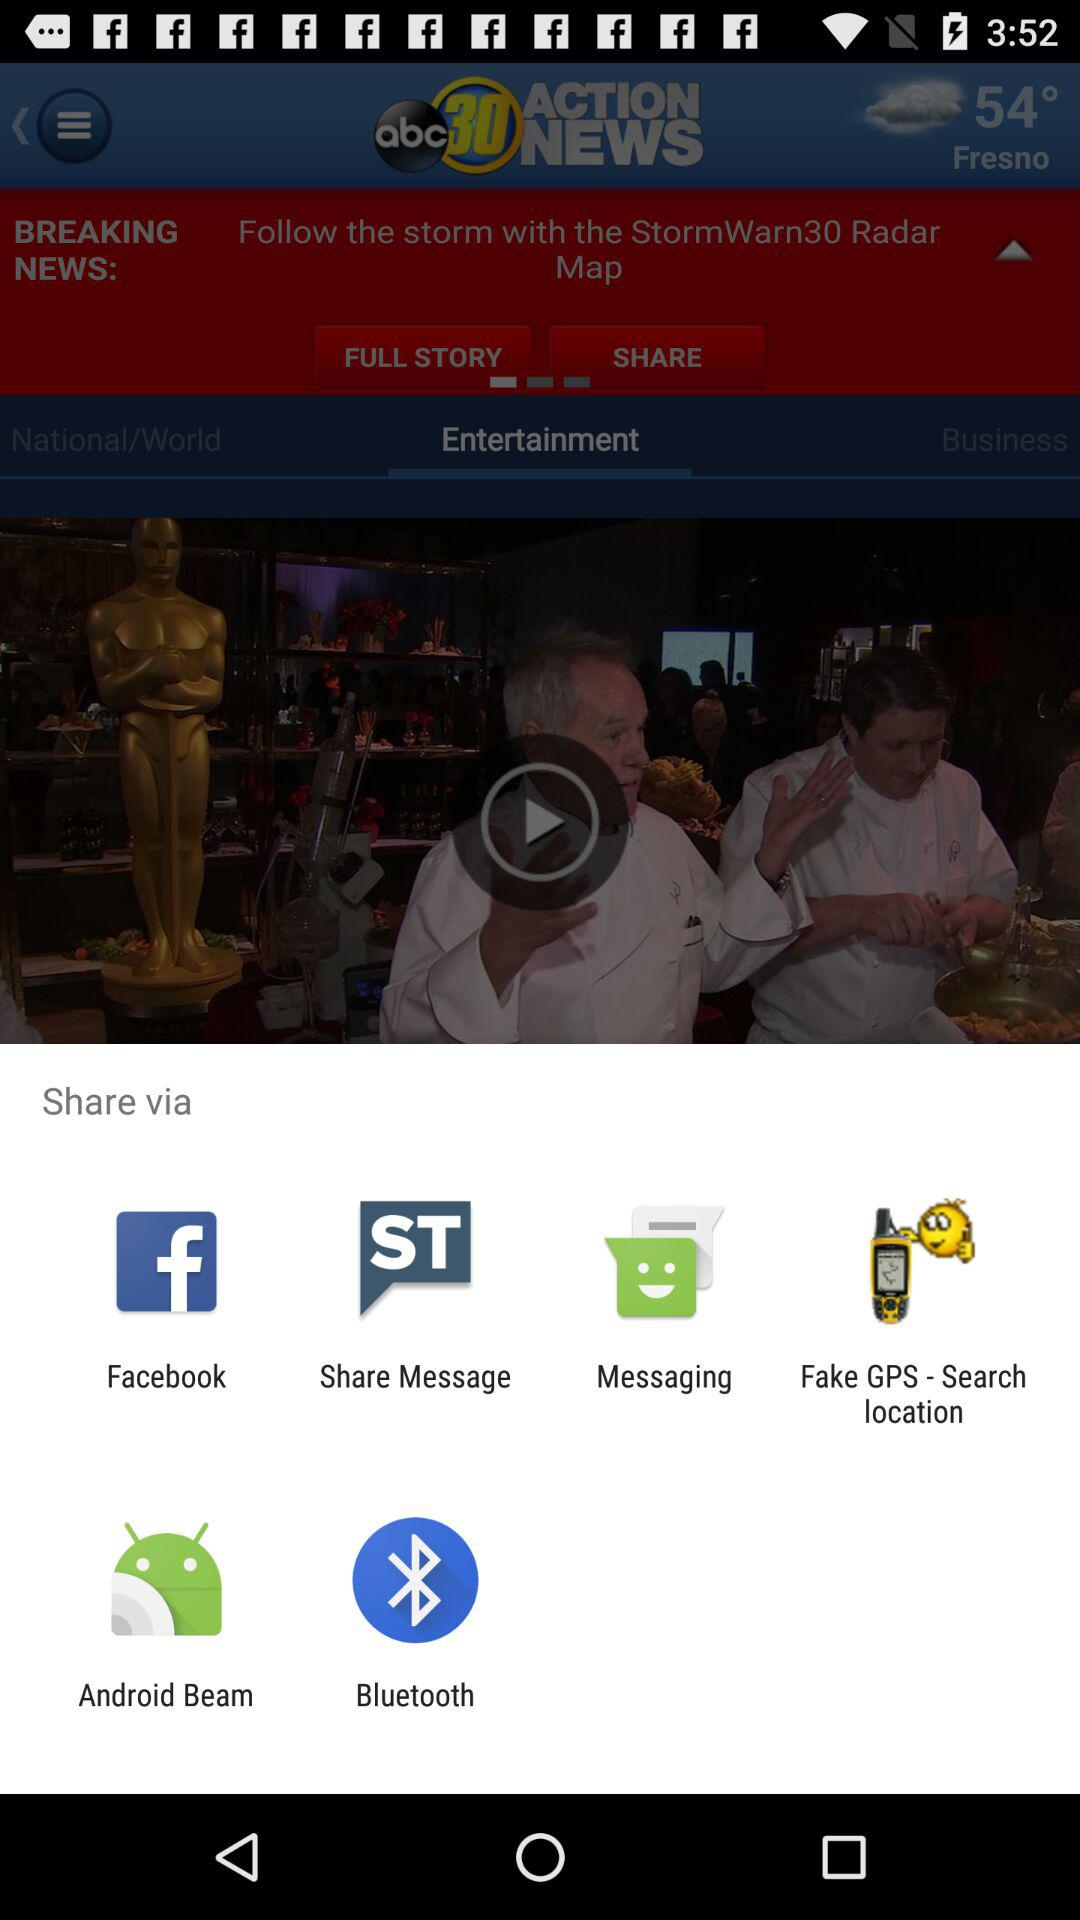Where will the storm hit first?
When the provided information is insufficient, respond with <no answer>. <no answer> 